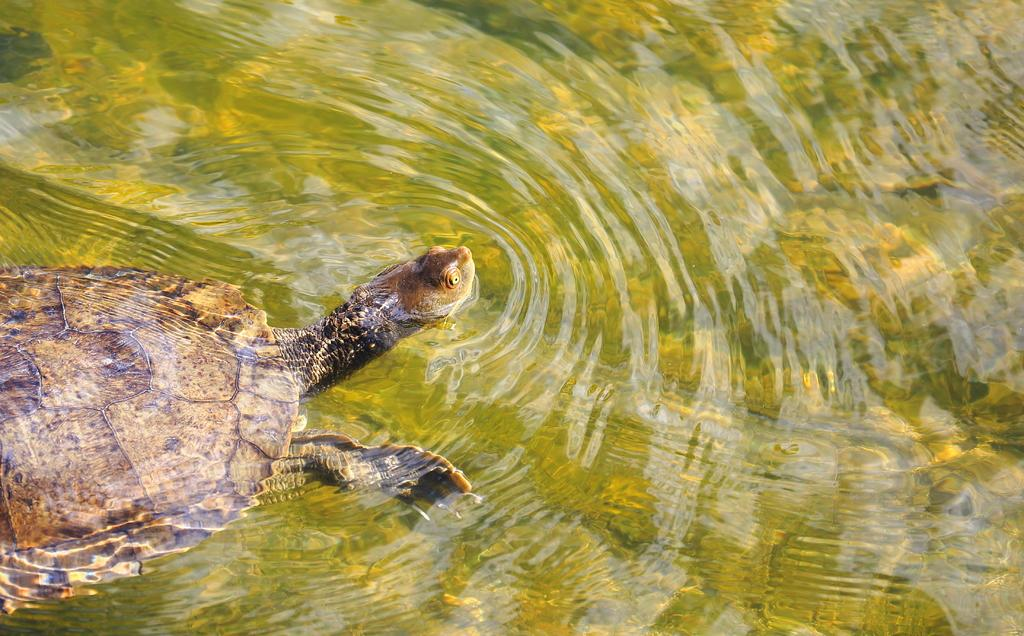What type of animal is in the image? There is a tortoise in the image. Where is the tortoise located? The tortoise is in water. How many babies are wearing hats in the image? There are no babies or hats present in the image; it features a tortoise in water. 